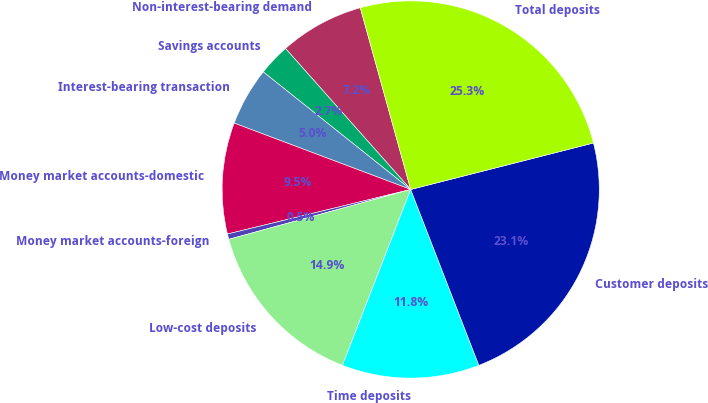Convert chart. <chart><loc_0><loc_0><loc_500><loc_500><pie_chart><fcel>Non-interest-bearing demand<fcel>Savings accounts<fcel>Interest-bearing transaction<fcel>Money market accounts-domestic<fcel>Money market accounts-foreign<fcel>Low-cost deposits<fcel>Time deposits<fcel>Customer deposits<fcel>Total deposits<nl><fcel>7.25%<fcel>2.73%<fcel>4.99%<fcel>9.52%<fcel>0.46%<fcel>14.85%<fcel>11.78%<fcel>23.08%<fcel>25.34%<nl></chart> 